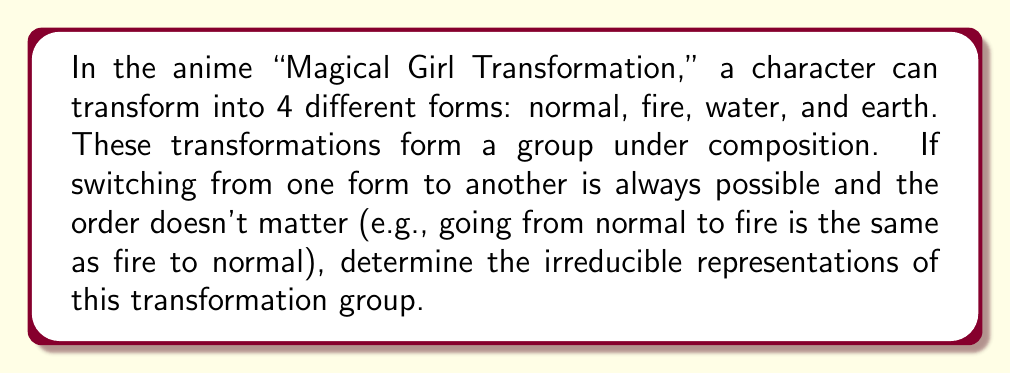Help me with this question. Let's approach this step-by-step:

1) First, we need to identify the group. Given the properties described, this is the Klein four-group $V_4$, isomorphic to $\mathbb{Z}_2 \times \mathbb{Z}_2$.

2) The group has 4 elements, let's call them $e$ (identity), $a$, $b$, and $c$, where:
   $e$ = staying in the current form
   $a$ = switching between normal and fire, or between water and earth
   $b$ = switching between normal and water, or between fire and earth
   $c$ = switching between normal and earth, or between fire and water

3) The character table for $V_4$ is:

   $$\begin{array}{c|cccc}
     & e & a & b & c \\
   \hline
   \chi_1 & 1 & 1 & 1 & 1 \\
   \chi_2 & 1 & 1 & -1 & -1 \\
   \chi_3 & 1 & -1 & 1 & -1 \\
   \chi_4 & 1 & -1 & -1 & 1
   \end{array}$$

4) Each row in this table represents an irreducible representation of $V_4$.

5) These are all 1-dimensional representations because $V_4$ is abelian, and for abelian groups, all irreducible representations are 1-dimensional.

6) In terms of the transformations:
   - $\chi_1$ is the trivial representation
   - $\chi_2$ represents the parity of water/fire transformations
   - $\chi_3$ represents the parity of fire/earth transformations
   - $\chi_4$ represents the parity of water/earth transformations
Answer: The group has four 1-dimensional irreducible representations: $\chi_1, \chi_2, \chi_3, \chi_4$. 